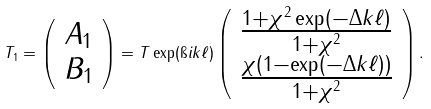Convert formula to latex. <formula><loc_0><loc_0><loc_500><loc_500>T _ { 1 } = \left ( \begin{array} { c } A _ { 1 } \\ B _ { 1 } \\ \end{array} \right ) = T \exp ( \i i k \ell ) \left ( \begin{array} { c } \frac { 1 + \chi ^ { 2 } \exp ( - \Delta k \ell ) } { 1 + \chi ^ { 2 } } \\ \frac { \chi ( 1 - \exp ( - \Delta k \ell ) ) } { 1 + \chi ^ { 2 } } \\ \end{array} \right ) .</formula> 